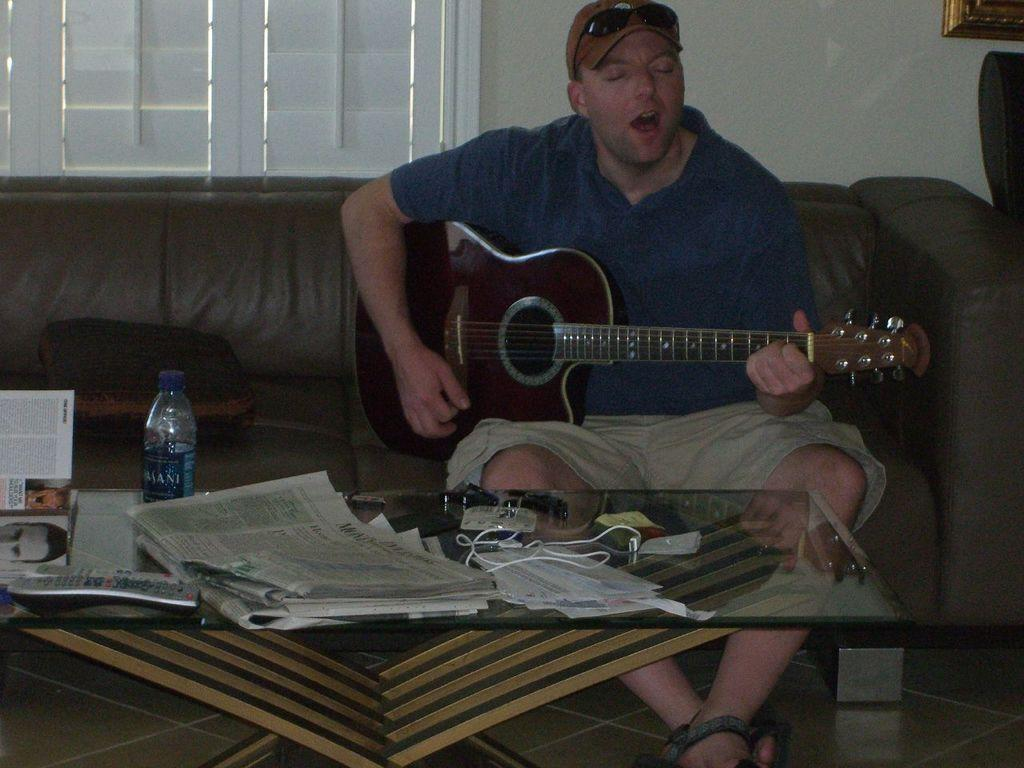What is the man in the image doing? The man is playing a guitar in the image. What objects are on the table in the image? There are papers and bottles on a table in the image. What can be seen in the background of the image? There is a window and a wall in the background of the image. What type of cabbage is being used as a stand for the guitar in the image? There is no cabbage present in the image, and the guitar is not being supported by any vegetable. 